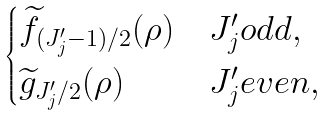<formula> <loc_0><loc_0><loc_500><loc_500>\begin{cases} \widetilde { f } _ { ( J ^ { \prime } _ { j } - 1 ) / 2 } ( \rho ) & J ^ { \prime } _ { j } o d d , \\ \widetilde { g } _ { J ^ { \prime } _ { j } / 2 } ( \rho ) & J ^ { \prime } _ { j } e v e n , \end{cases}</formula> 